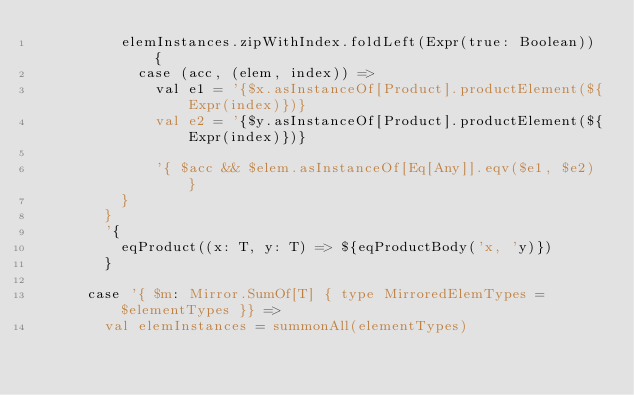Convert code to text. <code><loc_0><loc_0><loc_500><loc_500><_Scala_>          elemInstances.zipWithIndex.foldLeft(Expr(true: Boolean)) {
            case (acc, (elem, index)) =>
              val e1 = '{$x.asInstanceOf[Product].productElement(${Expr(index)})}
              val e2 = '{$y.asInstanceOf[Product].productElement(${Expr(index)})}

              '{ $acc && $elem.asInstanceOf[Eq[Any]].eqv($e1, $e2) }
          }
        }
        '{
          eqProduct((x: T, y: T) => ${eqProductBody('x, 'y)})
        }

      case '{ $m: Mirror.SumOf[T] { type MirroredElemTypes = $elementTypes }} =>
        val elemInstances = summonAll(elementTypes)</code> 